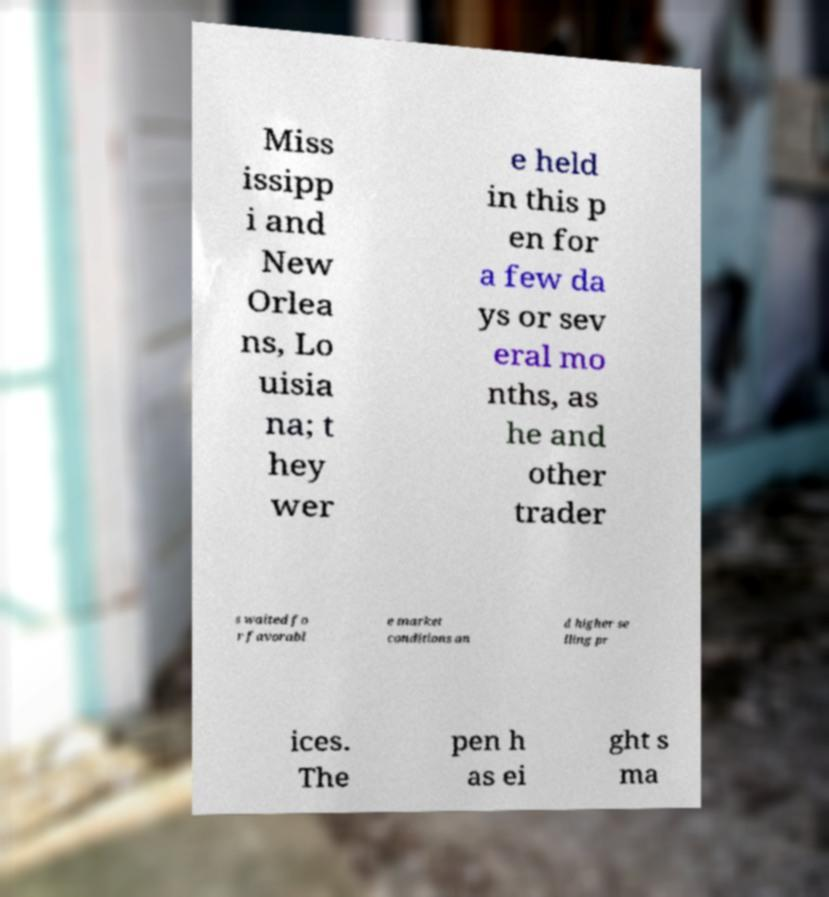There's text embedded in this image that I need extracted. Can you transcribe it verbatim? Miss issipp i and New Orlea ns, Lo uisia na; t hey wer e held in this p en for a few da ys or sev eral mo nths, as he and other trader s waited fo r favorabl e market conditions an d higher se lling pr ices. The pen h as ei ght s ma 